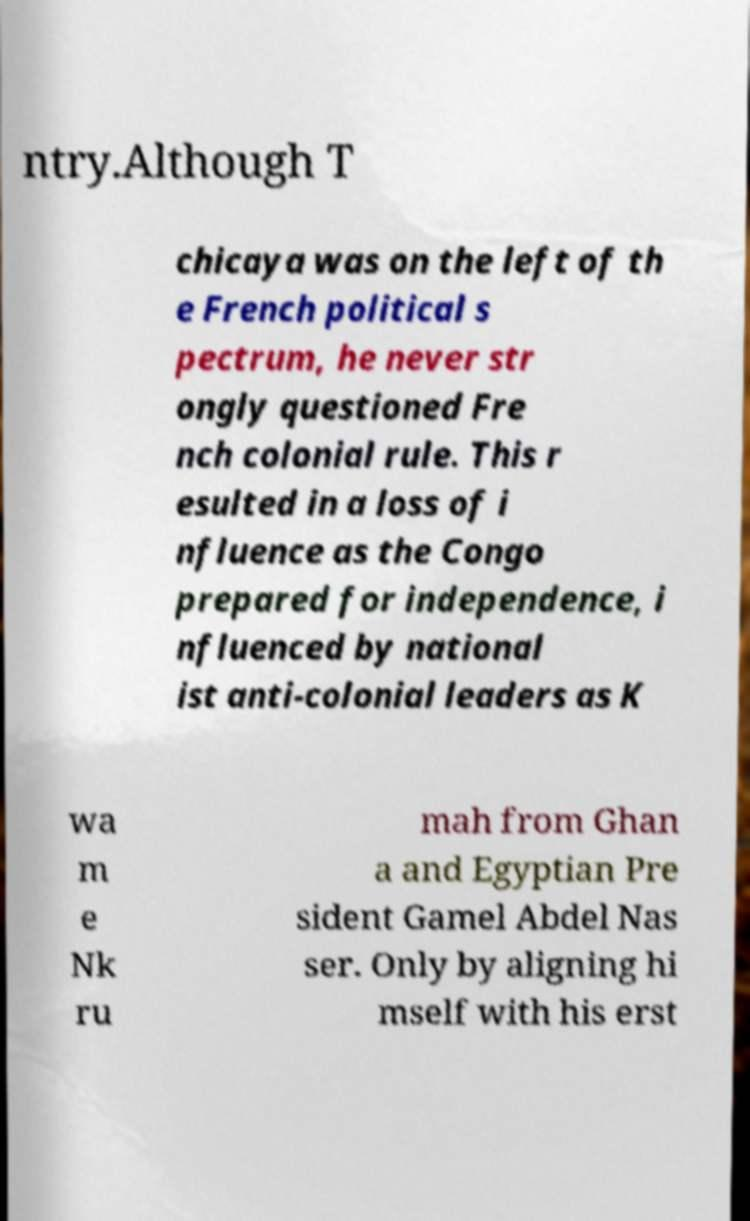Could you extract and type out the text from this image? ntry.Although T chicaya was on the left of th e French political s pectrum, he never str ongly questioned Fre nch colonial rule. This r esulted in a loss of i nfluence as the Congo prepared for independence, i nfluenced by national ist anti-colonial leaders as K wa m e Nk ru mah from Ghan a and Egyptian Pre sident Gamel Abdel Nas ser. Only by aligning hi mself with his erst 